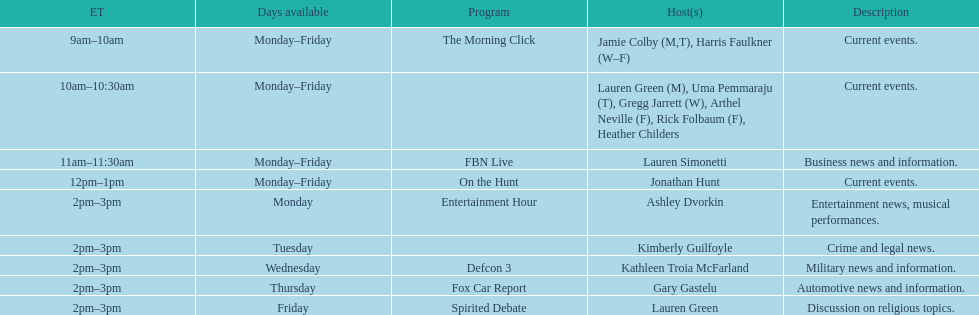For how many days in a week is fbn live available? 5. 